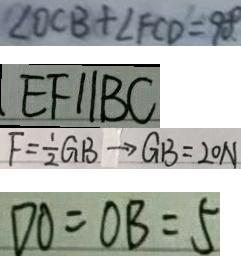Convert formula to latex. <formula><loc_0><loc_0><loc_500><loc_500>\angle O C B + \angle F C D = 9 0 . ^ { \circ } 
 E F / / B C 
 F = \frac { 1 } { 2 } G B \rightarrow G B = 2 0 N 
 D O = O B = 5</formula> 